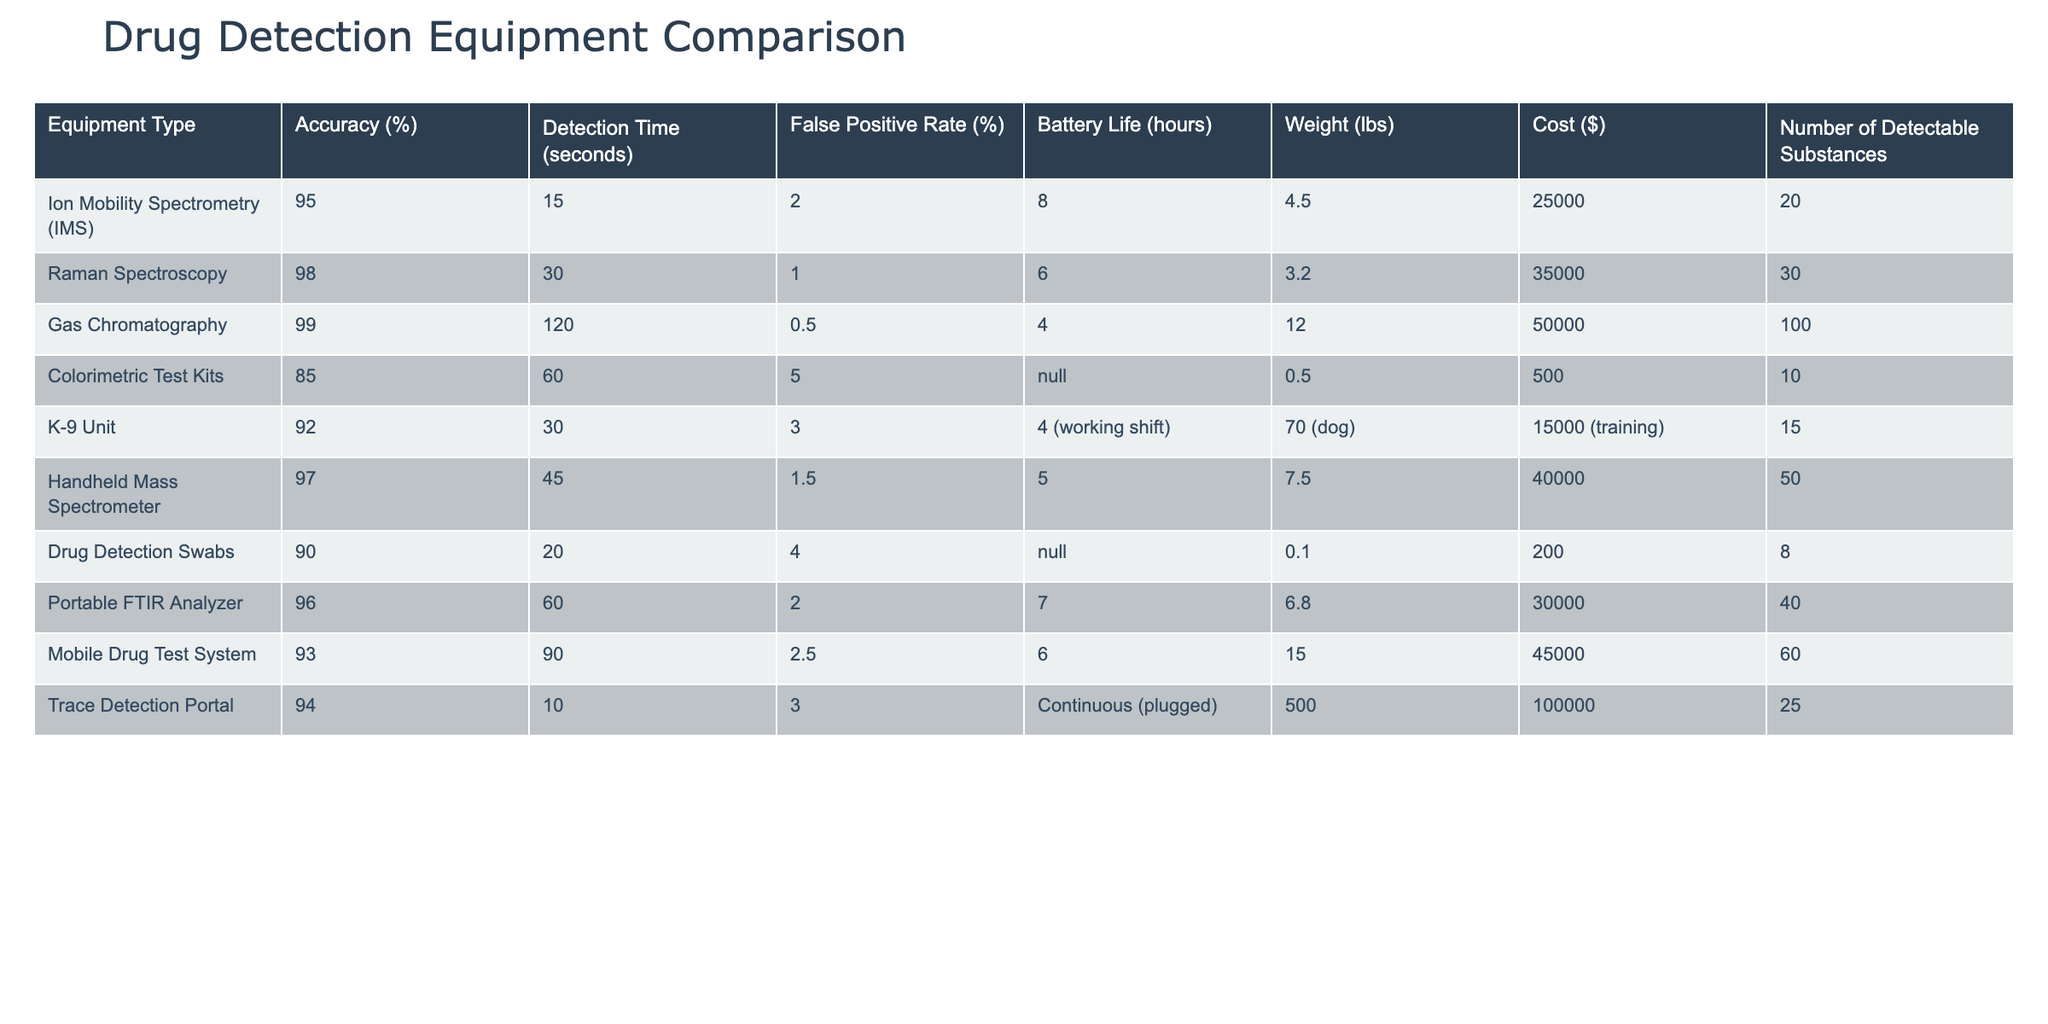What is the accuracy of the Gas Chromatography equipment? The accuracy value for Gas Chromatography equipment is listed in the table and can be found in the "Accuracy (%)" column for that specific row. It shows 99%.
Answer: 99% Which equipment type has the highest number of detectable substances? By checking the "Number of Detectable Substances" column, we find the values for each equipment type. Gas Chromatography has the highest number at 100.
Answer: 100 Is the False Positive Rate for Raman Spectroscopy lower than that for the K-9 unit? The False Positive Rate for Raman Spectroscopy is 1% while for the K-9 unit, it is 3%. Since 1% is less than 3%, the statement is true.
Answer: Yes What is the total weight of the equipment types that have a battery life of at least 6 hours? We review the battery life and corresponding weights of the equipment. The applicable types are Gas Chromatography (12 lbs), K-9 Unit (70 lbs), and Trace Detection Portal (500 lbs). The total weight is 12 + 70 + 500 = 582 lbs.
Answer: 582 lbs How does the average detection time compare between handheld mass spectrometers and drug detection swabs? The detection times for both are compared. Handheld Mass Spectrometer has a detection time of 45 seconds while Drug Detection Swabs have 20 seconds, resulting in an average of (45 + 20) / 2 = 32.5 seconds. The specific average of handheld mass spectrometers is higher.
Answer: Handheld mass spectrometers are higher What is the difference in cost between the most and least expensive equipment? Looking at the "Cost ($)" column, the most expensive is Gas Chromatography at $50,000 and the least expensive is Colorimetric Test Kits at $500. The difference is 50000 - 500 = 49500.
Answer: 49500 Does the equipment with the shortest detection time also have the highest accuracy? The equipment with the shortest detection time is the Trace Detection Portal at 10 seconds with an accuracy of 94%. Gas Chromatography has the highest accuracy at 99% but takes considerably longer at 120 seconds. Thus, the statement is false.
Answer: No Which equipment type has the best trade-off between cost and accuracy among those listed? By assessing the ratio of cost to accuracy for each device, we look for the lowest ratio of cost to accuracy values. Calculating these provides insights on trade-offs, with K-9 Unit showing a reasonable balance and a cost of $15,000 for 92% accuracy.
Answer: K-9 Unit How many pieces of equipment have a false positive rate less than 2%? By reviewing the "False Positive Rate (%)" column, we find that the equipment types with less than 2% are Raman Spectroscopy (1%), Handheld Mass Spectrometer (1.5%), and Gas Chromatography (0.5%). This totals 3 pieces of equipment.
Answer: 3 